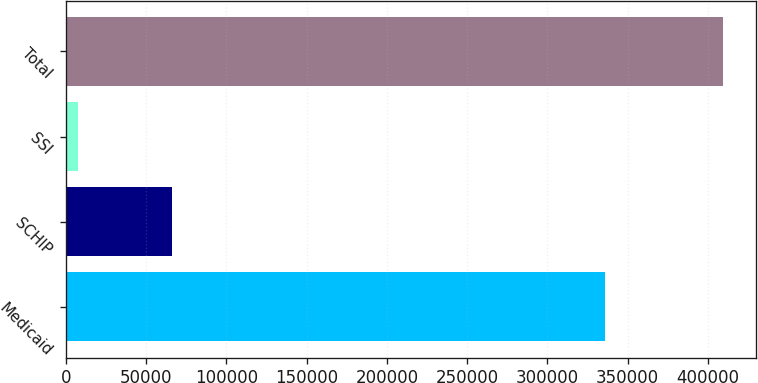Convert chart to OTSL. <chart><loc_0><loc_0><loc_500><loc_500><bar_chart><fcel>Medicaid<fcel>SCHIP<fcel>SSI<fcel>Total<nl><fcel>336100<fcel>65900<fcel>7600<fcel>409600<nl></chart> 